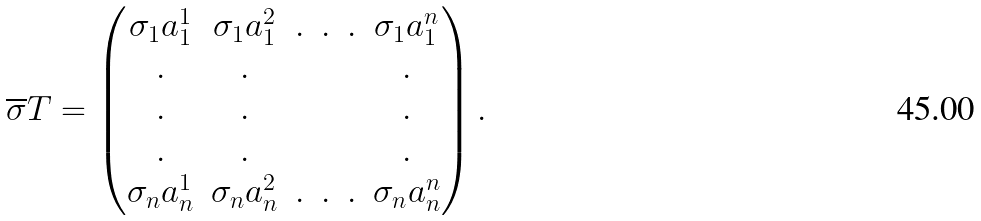<formula> <loc_0><loc_0><loc_500><loc_500>\overline { \sigma } T = \begin{pmatrix} \sigma _ { 1 } a _ { 1 } ^ { 1 } & \sigma _ { 1 } a _ { 1 } ^ { 2 } & . & . & . & \sigma _ { 1 } a _ { 1 } ^ { n } \\ . & . & & & & . \\ . & . & & & & . \\ . & . & & & & . \\ \sigma _ { n } a _ { n } ^ { 1 } & \sigma _ { n } a _ { n } ^ { 2 } & . & . & . & \sigma _ { n } a _ { n } ^ { n } \end{pmatrix} .</formula> 